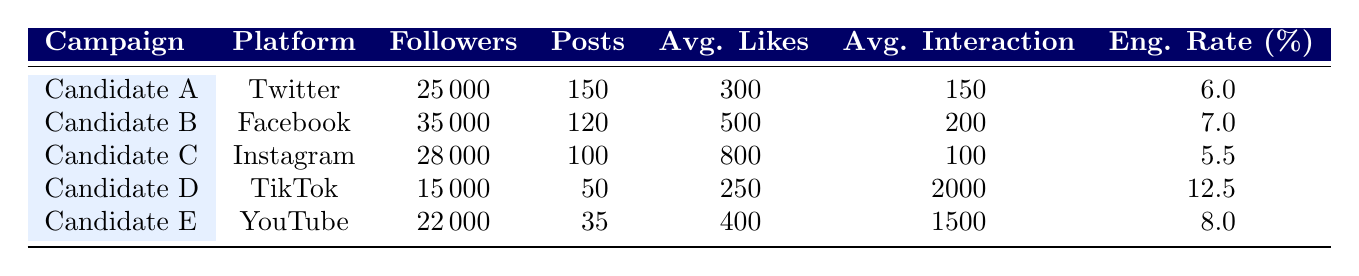What is the engagement rate of Candidate D's TikTok campaign? The table lists the engagement rates for each campaign. For Candidate D, the engagement rate is provided in the last column. I can see that it shows 12.5 percent.
Answer: 12.5 Which candidate had the highest average likes per post on Instagram? By looking at the average likes per post for each candidate on Instagram, I find that Candidate C has an average of 800 likes per post, which is the highest among the candidates listed.
Answer: Candidate C Is it true that Candidate B had more followers than Candidate E? The table displays the number of followers for each candidate. Candidate B has 35,000 followers and Candidate E has 22,000 followers. Since 35,000 is greater than 22,000, the statement is true.
Answer: Yes How many total posts did Candidate A and Candidate C make combined? I need to find the total number of posts made by Candidate A and Candidate C. Candidate A made 150 posts and Candidate C made 100 posts. Adding these together, 150 + 100 equals 250 total posts.
Answer: 250 What is the average number of likes per post for candidates who used Facebook and YouTube? First, I note the average likes per post for Facebook (Candidate B) is 500 and for YouTube (Candidate E) is 400. To find the average, I sum these two values (500 + 400 = 900) and divide by 2, giving 900/2 = 450.
Answer: 450 Which campaign had the lowest total number of posts? Looking through the total posts column, I see that Candidate E only made 35 posts. Since this is lower than the other candidates listed, I conclude that Candidate E had the lowest total number of posts.
Answer: Candidate E How does the engagement rate of TikTok compare to that of Instagram? The engagement rate for TikTok (Candidate D) is 12.5 percent, while for Instagram (Candidate C) it is 5.5 percent. By comparing these two values, I conclude that TikTok has a significantly higher engagement rate than Instagram.
Answer: TikTok is higher What is the difference in average interaction metrics between Candidate D and Candidate E? Candidate D has an average interaction metric of 2000 and Candidate E has 1500. To find the difference, I subtract Candidate E's interaction metric from Candidate D's. Hence, 2000 - 1500 equals 500.
Answer: 500 